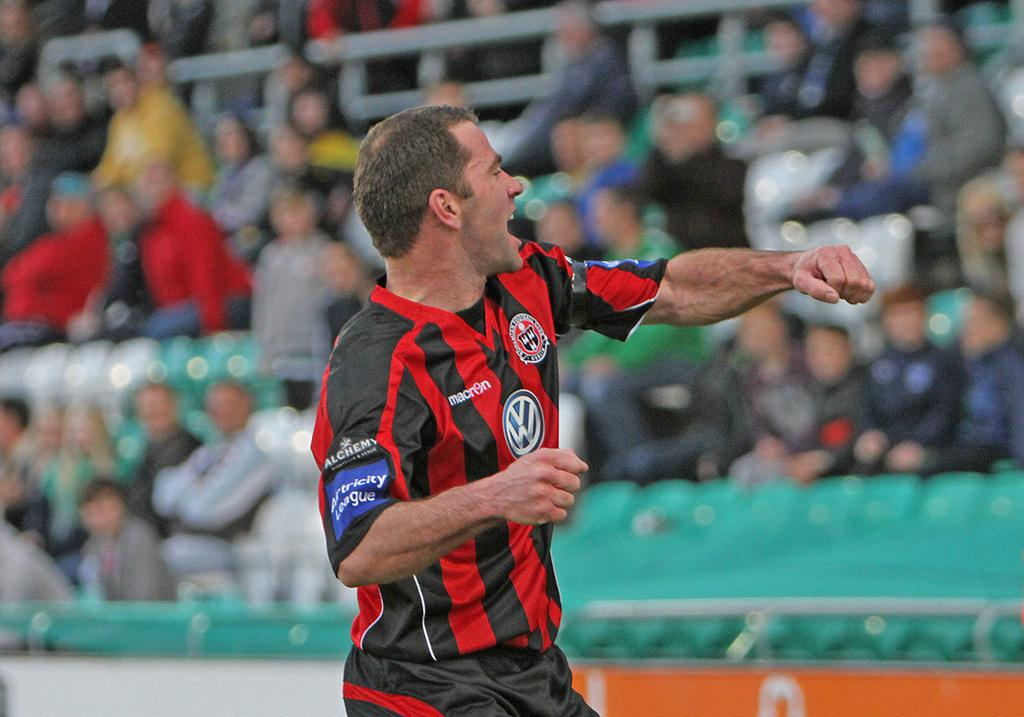Provide a one-sentence caption for the provided image. a man wearing a soccer jersey that says macri9n. 